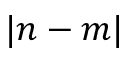<formula> <loc_0><loc_0><loc_500><loc_500>| n - m |</formula> 